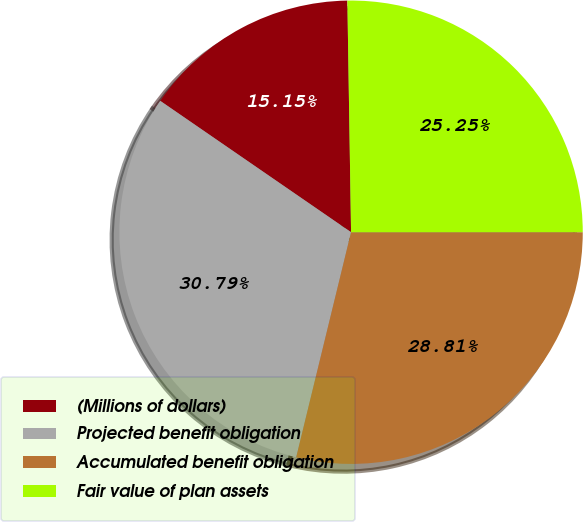Convert chart. <chart><loc_0><loc_0><loc_500><loc_500><pie_chart><fcel>(Millions of dollars)<fcel>Projected benefit obligation<fcel>Accumulated benefit obligation<fcel>Fair value of plan assets<nl><fcel>15.15%<fcel>30.79%<fcel>28.81%<fcel>25.25%<nl></chart> 